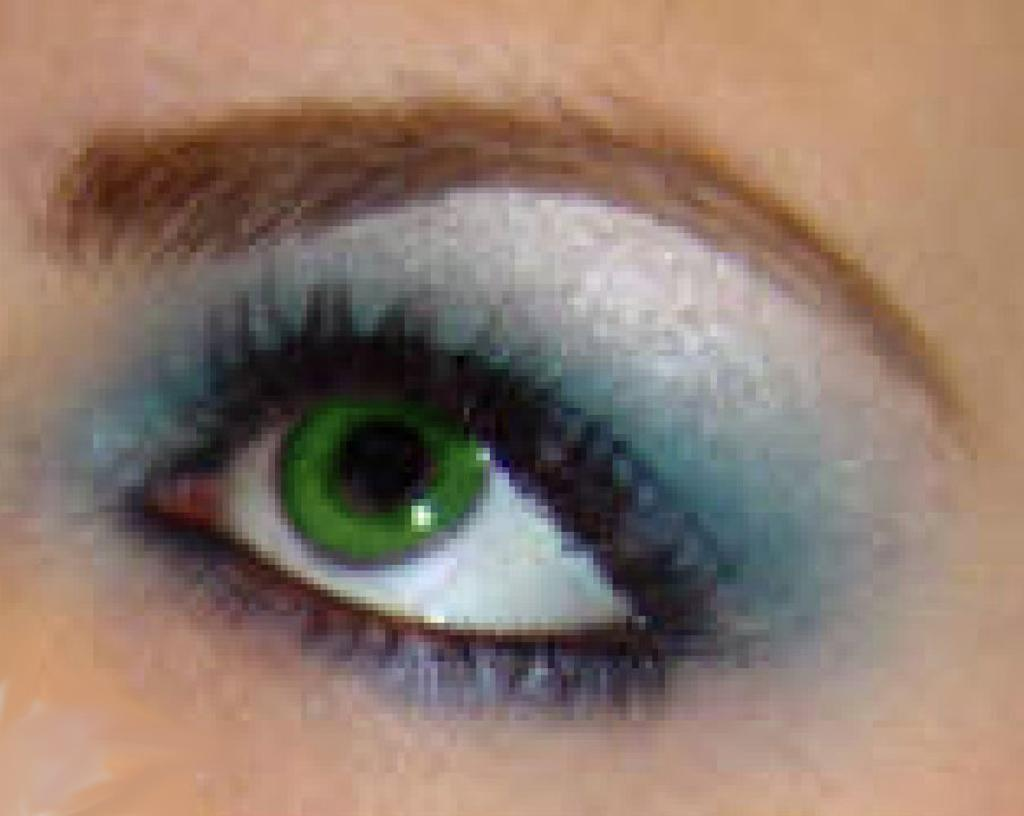What body part is the main subject of the image? There is an eye in the image. What other facial feature is visible in the image? There is an eyebrow in the image. To whom do the eye and eyebrow belong? Both the eye and eyebrow belong to a woman. What type of house is visible in the image? There is no house present in the image; it features an eye and an eyebrow. Is there any volcanic activity visible in the image? There is no volcanic activity present in the image; it features an eye and an eyebrow. 